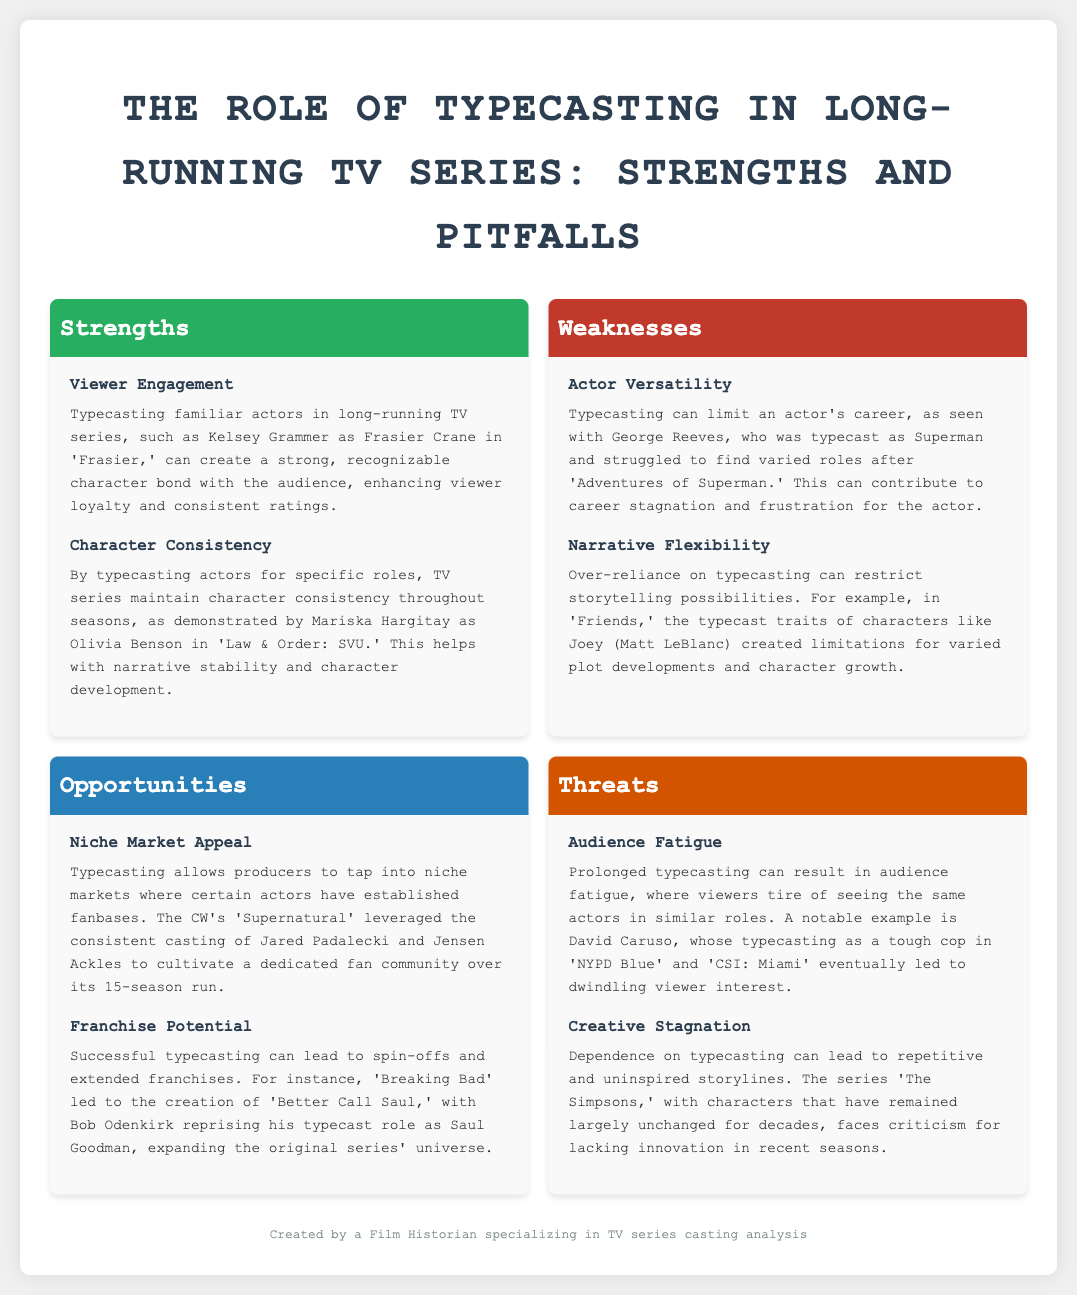What is the title of the document? The title is found at the top of the document, indicating the main subject of the SWOT analysis.
Answer: The Role of Typecasting in Long-running TV Series: Strengths and Pitfalls Who played Frasier Crane on 'Frasier'? The character of Frasier Crane was portrayed by a well-known actor, as mentioned in the strengths section.
Answer: Kelsey Grammer What character did Mariska Hargitay portray? The document specifies the role that Mariska Hargitay is typecast in, providing insight into character consistency.
Answer: Olivia Benson Which show led to the spin-off 'Better Call Saul'? The document outlines a successful franchise that emerged from a prior series, illustrating the opportunity created by typecasting.
Answer: Breaking Bad What is one weakness related to actor versatility? The weaknesses section highlights a specific problem that arises from typecasting, which is mentioned explicitly.
Answer: Limits an actor's career Which actor is associated with audience fatigue in the threats section? The threats section cites an example of an actor who experienced audience fatigue due to typecasting in his roles.
Answer: David Caruso What does typecasting help producers tap into according to the opportunities section? The document indicates a market strategy related to established fanbases that can benefit from typecasting.
Answer: Niche markets What long-running TV series featured Jared Padalecki and Jensen Ackles? The opportunities section gives an example of a series that successfully used typecasting to create a dedicated fan community.
Answer: Supernatural What kind of stagnation can typecasting lead to in narratives? The threats section points out a specific type of narrative problem associated with an over-reliance on typecasting.
Answer: Creative stagnation 